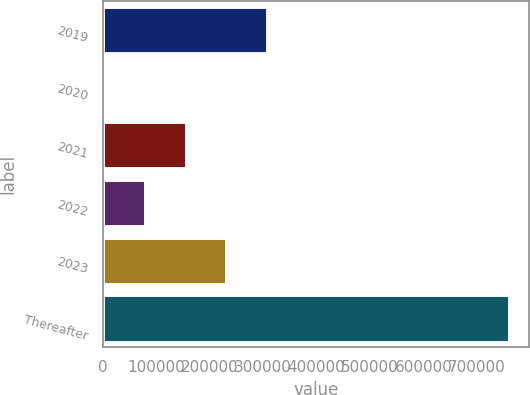Convert chart to OTSL. <chart><loc_0><loc_0><loc_500><loc_500><bar_chart><fcel>2019<fcel>2020<fcel>2021<fcel>2022<fcel>2023<fcel>Thereafter<nl><fcel>306733<fcel>4729<fcel>155731<fcel>80230.1<fcel>231232<fcel>759740<nl></chart> 